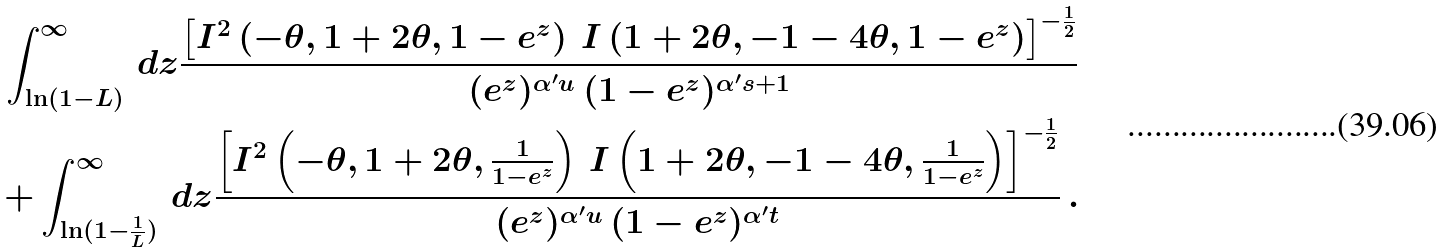Convert formula to latex. <formula><loc_0><loc_0><loc_500><loc_500>\int ^ { \infty } _ { \ln ( 1 - L ) } \, d z \frac { \left [ I ^ { 2 } \left ( - \theta , 1 + 2 \theta , 1 - e ^ { z } \right ) \, I \left ( 1 + 2 \theta , - 1 - 4 \theta , 1 - e ^ { z } \right ) \right ] ^ { - \frac { 1 } { 2 } } } { ( e ^ { z } ) ^ { \alpha ^ { \prime } u } \, ( 1 - e ^ { z } ) ^ { \alpha ^ { \prime } s + 1 } } \\ + \int ^ { \infty } _ { \ln ( 1 - \frac { 1 } { L } ) } \, d z \frac { \left [ I ^ { 2 } \left ( - \theta , 1 + 2 \theta , \frac { 1 } { 1 - e ^ { z } } \right ) \, I \left ( 1 + 2 \theta , - 1 - 4 \theta , \frac { 1 } { 1 - e ^ { z } } \right ) \right ] ^ { - \frac { 1 } { 2 } } } { ( e ^ { z } ) ^ { \alpha ^ { \prime } u } \, ( 1 - e ^ { z } ) ^ { \alpha ^ { \prime } t } } \, .</formula> 